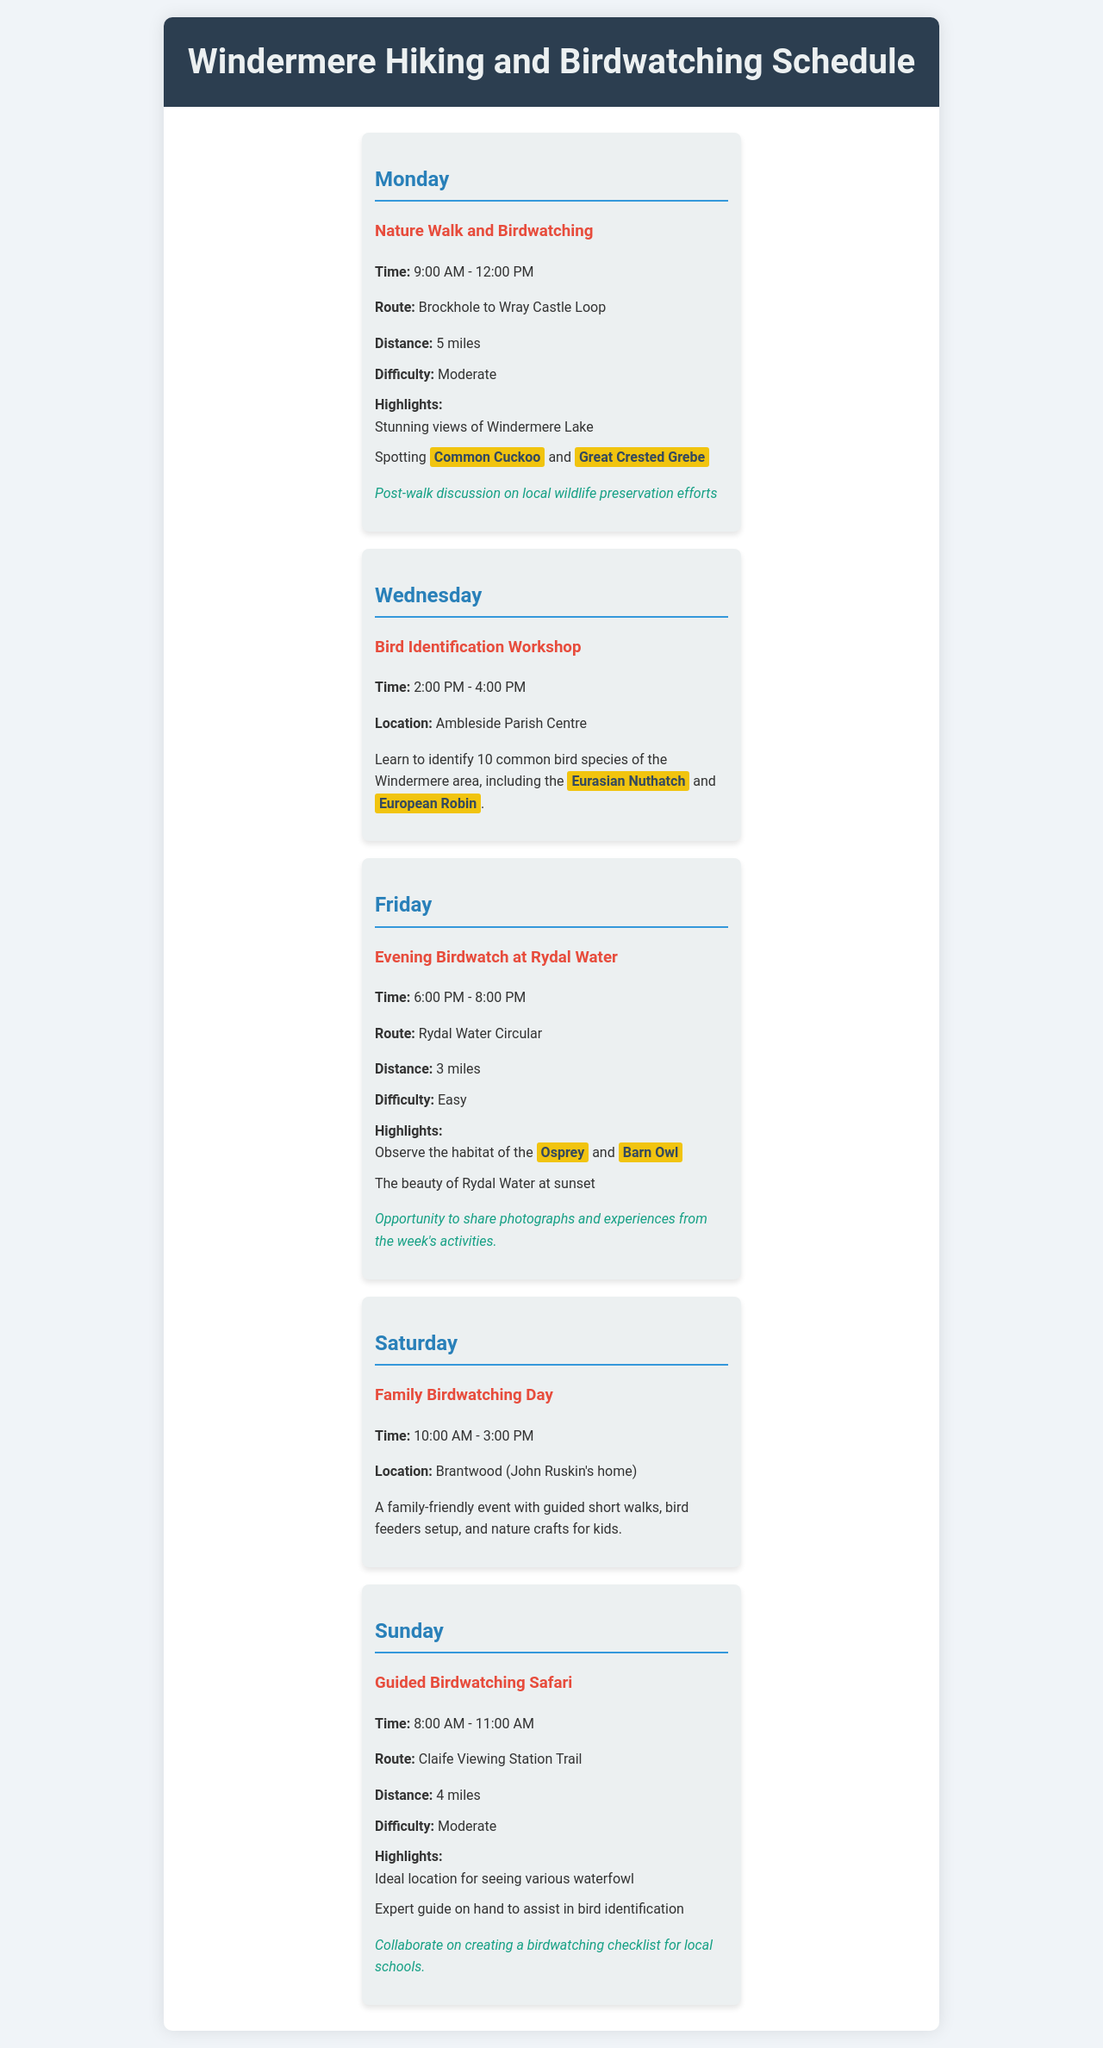What is the time for the Nature Walk and Birdwatching? The time for the Nature Walk and Birdwatching activity is provided in the document as 9:00 AM - 12:00 PM.
Answer: 9:00 AM - 12:00 PM How long is the Rydal Water Circular route? The document specifies that the distance for the Rydal Water Circular route is 3 miles.
Answer: 3 miles Which bird species is highlighted for spotting on Monday? The document highlights specific bird species that can be spotted during the Nature Walk, including the Common Cuckoo and Great Crested Grebe.
Answer: Common Cuckoo and Great Crested Grebe What workshop is held on Wednesday? The document describes a Bird Identification Workshop scheduled for Wednesday.
Answer: Bird Identification Workshop What is the location for the Family Birdwatching Day? The document states that the Family Birdwatching Day takes place at Brantwood.
Answer: Brantwood What is the engagement activity after the Evening Birdwatch? The document mentions that participants have the opportunity to share photographs and experiences from the week's activities as an engagement activity.
Answer: Share photographs and experiences How many bird species are participants going to learn to identify in the Bird Identification Workshop? The document indicates that participants will learn to identify 10 common bird species during the workshop.
Answer: 10 What is the difficulty level of the Guided Birdwatching Safari? The document mentions that the Guided Birdwatching Safari has a difficulty level categorized as Moderate.
Answer: Moderate What event is scheduled for Saturday? The document specifies that the event scheduled for Saturday is Family Birdwatching Day.
Answer: Family Birdwatching Day 